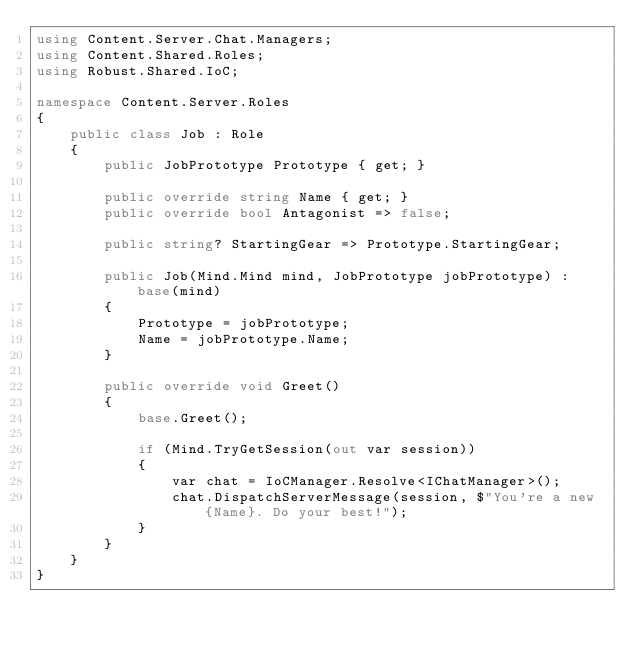Convert code to text. <code><loc_0><loc_0><loc_500><loc_500><_C#_>using Content.Server.Chat.Managers;
using Content.Shared.Roles;
using Robust.Shared.IoC;

namespace Content.Server.Roles
{
    public class Job : Role
    {
        public JobPrototype Prototype { get; }

        public override string Name { get; }
        public override bool Antagonist => false;

        public string? StartingGear => Prototype.StartingGear;

        public Job(Mind.Mind mind, JobPrototype jobPrototype) : base(mind)
        {
            Prototype = jobPrototype;
            Name = jobPrototype.Name;
        }

        public override void Greet()
        {
            base.Greet();

            if (Mind.TryGetSession(out var session))
            {
                var chat = IoCManager.Resolve<IChatManager>();
                chat.DispatchServerMessage(session, $"You're a new {Name}. Do your best!");
            }
        }
    }
}
</code> 